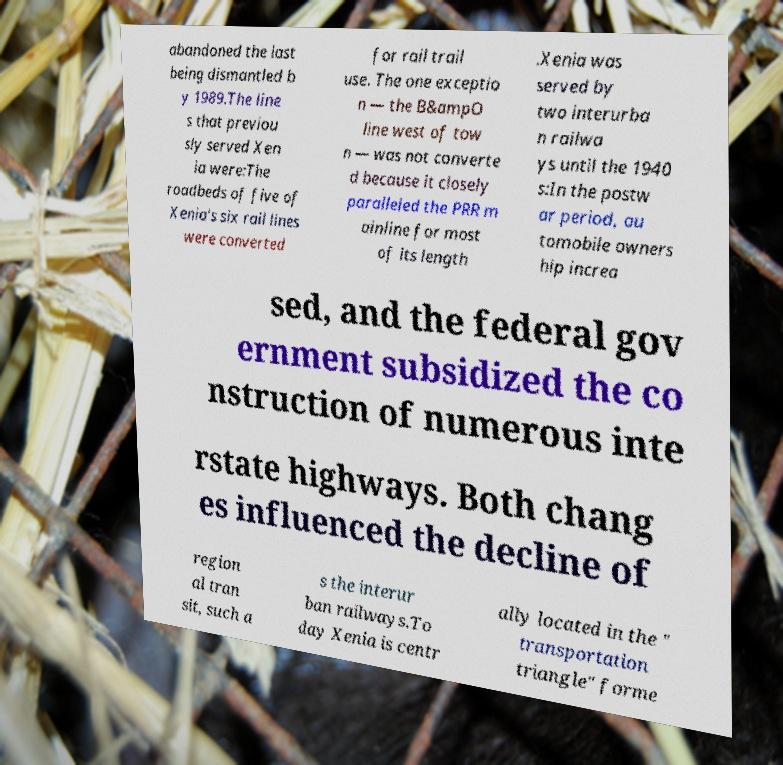Can you accurately transcribe the text from the provided image for me? abandoned the last being dismantled b y 1989.The line s that previou sly served Xen ia were:The roadbeds of five of Xenia's six rail lines were converted for rail trail use. The one exceptio n — the B&ampO line west of tow n — was not converte d because it closely paralleled the PRR m ainline for most of its length .Xenia was served by two interurba n railwa ys until the 1940 s:In the postw ar period, au tomobile owners hip increa sed, and the federal gov ernment subsidized the co nstruction of numerous inte rstate highways. Both chang es influenced the decline of region al tran sit, such a s the interur ban railways.To day Xenia is centr ally located in the " transportation triangle" forme 